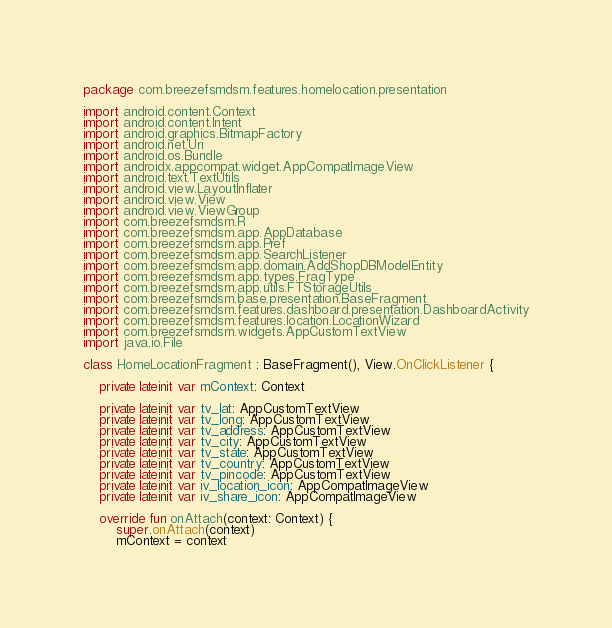<code> <loc_0><loc_0><loc_500><loc_500><_Kotlin_>package com.breezefsmdsm.features.homelocation.presentation

import android.content.Context
import android.content.Intent
import android.graphics.BitmapFactory
import android.net.Uri
import android.os.Bundle
import androidx.appcompat.widget.AppCompatImageView
import android.text.TextUtils
import android.view.LayoutInflater
import android.view.View
import android.view.ViewGroup
import com.breezefsmdsm.R
import com.breezefsmdsm.app.AppDatabase
import com.breezefsmdsm.app.Pref
import com.breezefsmdsm.app.SearchListener
import com.breezefsmdsm.app.domain.AddShopDBModelEntity
import com.breezefsmdsm.app.types.FragType
import com.breezefsmdsm.app.utils.FTStorageUtils
import com.breezefsmdsm.base.presentation.BaseFragment
import com.breezefsmdsm.features.dashboard.presentation.DashboardActivity
import com.breezefsmdsm.features.location.LocationWizard
import com.breezefsmdsm.widgets.AppCustomTextView
import java.io.File

class HomeLocationFragment : BaseFragment(), View.OnClickListener {

    private lateinit var mContext: Context

    private lateinit var tv_lat: AppCustomTextView
    private lateinit var tv_long: AppCustomTextView
    private lateinit var tv_address: AppCustomTextView
    private lateinit var tv_city: AppCustomTextView
    private lateinit var tv_state: AppCustomTextView
    private lateinit var tv_country: AppCustomTextView
    private lateinit var tv_pincode: AppCustomTextView
    private lateinit var iv_location_icon: AppCompatImageView
    private lateinit var iv_share_icon: AppCompatImageView

    override fun onAttach(context: Context) {
        super.onAttach(context)
        mContext = context</code> 